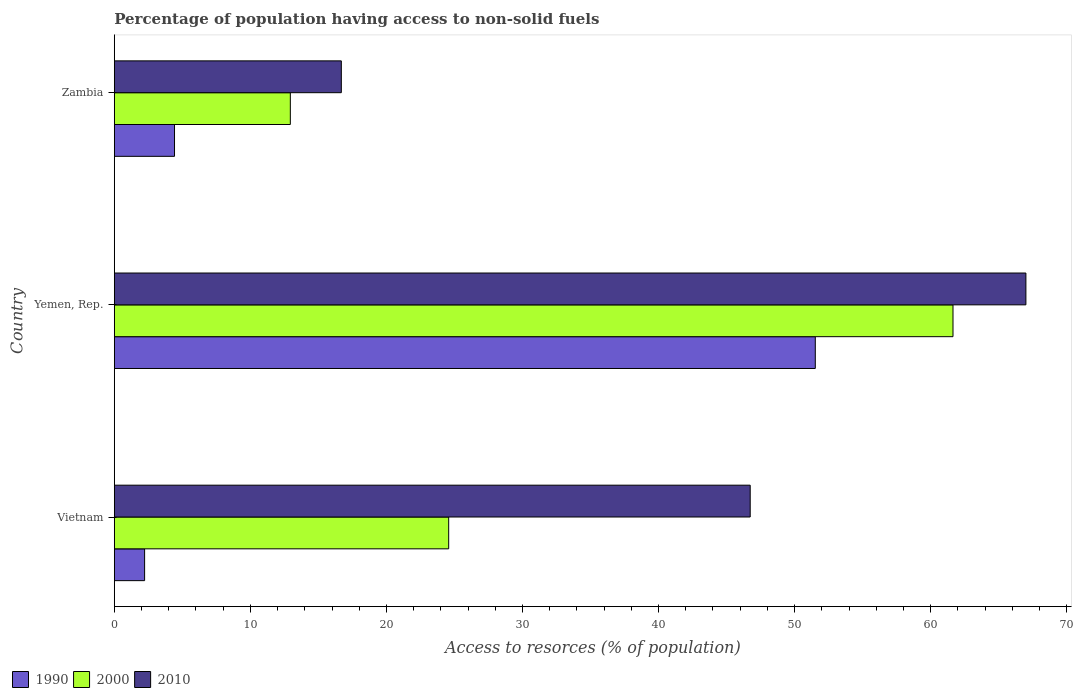Are the number of bars per tick equal to the number of legend labels?
Offer a terse response. Yes. How many bars are there on the 1st tick from the bottom?
Offer a terse response. 3. What is the label of the 2nd group of bars from the top?
Offer a very short reply. Yemen, Rep. What is the percentage of population having access to non-solid fuels in 2010 in Vietnam?
Offer a very short reply. 46.74. Across all countries, what is the maximum percentage of population having access to non-solid fuels in 2000?
Offer a terse response. 61.64. Across all countries, what is the minimum percentage of population having access to non-solid fuels in 1990?
Make the answer very short. 2.23. In which country was the percentage of population having access to non-solid fuels in 1990 maximum?
Ensure brevity in your answer.  Yemen, Rep. In which country was the percentage of population having access to non-solid fuels in 2000 minimum?
Keep it short and to the point. Zambia. What is the total percentage of population having access to non-solid fuels in 1990 in the graph?
Provide a succinct answer. 58.17. What is the difference between the percentage of population having access to non-solid fuels in 2000 in Vietnam and that in Yemen, Rep.?
Offer a terse response. -37.07. What is the difference between the percentage of population having access to non-solid fuels in 1990 in Yemen, Rep. and the percentage of population having access to non-solid fuels in 2000 in Zambia?
Provide a succinct answer. 38.58. What is the average percentage of population having access to non-solid fuels in 1990 per country?
Offer a terse response. 19.39. What is the difference between the percentage of population having access to non-solid fuels in 2010 and percentage of population having access to non-solid fuels in 2000 in Yemen, Rep.?
Give a very brief answer. 5.36. In how many countries, is the percentage of population having access to non-solid fuels in 1990 greater than 18 %?
Offer a terse response. 1. What is the ratio of the percentage of population having access to non-solid fuels in 2000 in Yemen, Rep. to that in Zambia?
Your response must be concise. 4.76. Is the percentage of population having access to non-solid fuels in 2000 in Yemen, Rep. less than that in Zambia?
Provide a short and direct response. No. What is the difference between the highest and the second highest percentage of population having access to non-solid fuels in 2000?
Keep it short and to the point. 37.07. What is the difference between the highest and the lowest percentage of population having access to non-solid fuels in 2010?
Your answer should be compact. 50.32. Is the sum of the percentage of population having access to non-solid fuels in 1990 in Vietnam and Yemen, Rep. greater than the maximum percentage of population having access to non-solid fuels in 2010 across all countries?
Your response must be concise. No. What does the 2nd bar from the bottom in Yemen, Rep. represents?
Give a very brief answer. 2000. Is it the case that in every country, the sum of the percentage of population having access to non-solid fuels in 2010 and percentage of population having access to non-solid fuels in 1990 is greater than the percentage of population having access to non-solid fuels in 2000?
Ensure brevity in your answer.  Yes. Are all the bars in the graph horizontal?
Your answer should be very brief. Yes. How many countries are there in the graph?
Keep it short and to the point. 3. What is the difference between two consecutive major ticks on the X-axis?
Keep it short and to the point. 10. Does the graph contain any zero values?
Provide a short and direct response. No. Does the graph contain grids?
Your response must be concise. No. What is the title of the graph?
Provide a succinct answer. Percentage of population having access to non-solid fuels. What is the label or title of the X-axis?
Provide a short and direct response. Access to resorces (% of population). What is the Access to resorces (% of population) in 1990 in Vietnam?
Make the answer very short. 2.23. What is the Access to resorces (% of population) of 2000 in Vietnam?
Your answer should be compact. 24.58. What is the Access to resorces (% of population) of 2010 in Vietnam?
Your answer should be compact. 46.74. What is the Access to resorces (% of population) of 1990 in Yemen, Rep.?
Your answer should be very brief. 51.52. What is the Access to resorces (% of population) in 2000 in Yemen, Rep.?
Ensure brevity in your answer.  61.64. What is the Access to resorces (% of population) of 2010 in Yemen, Rep.?
Ensure brevity in your answer.  67. What is the Access to resorces (% of population) in 1990 in Zambia?
Provide a short and direct response. 4.42. What is the Access to resorces (% of population) of 2000 in Zambia?
Your answer should be very brief. 12.94. What is the Access to resorces (% of population) in 2010 in Zambia?
Provide a short and direct response. 16.69. Across all countries, what is the maximum Access to resorces (% of population) in 1990?
Provide a succinct answer. 51.52. Across all countries, what is the maximum Access to resorces (% of population) in 2000?
Your response must be concise. 61.64. Across all countries, what is the maximum Access to resorces (% of population) of 2010?
Your answer should be compact. 67. Across all countries, what is the minimum Access to resorces (% of population) in 1990?
Provide a succinct answer. 2.23. Across all countries, what is the minimum Access to resorces (% of population) in 2000?
Provide a short and direct response. 12.94. Across all countries, what is the minimum Access to resorces (% of population) in 2010?
Your answer should be compact. 16.69. What is the total Access to resorces (% of population) in 1990 in the graph?
Offer a terse response. 58.17. What is the total Access to resorces (% of population) of 2000 in the graph?
Offer a terse response. 99.16. What is the total Access to resorces (% of population) in 2010 in the graph?
Your answer should be compact. 130.43. What is the difference between the Access to resorces (% of population) in 1990 in Vietnam and that in Yemen, Rep.?
Your answer should be compact. -49.29. What is the difference between the Access to resorces (% of population) of 2000 in Vietnam and that in Yemen, Rep.?
Provide a succinct answer. -37.07. What is the difference between the Access to resorces (% of population) of 2010 in Vietnam and that in Yemen, Rep.?
Your answer should be very brief. -20.26. What is the difference between the Access to resorces (% of population) of 1990 in Vietnam and that in Zambia?
Make the answer very short. -2.2. What is the difference between the Access to resorces (% of population) in 2000 in Vietnam and that in Zambia?
Provide a succinct answer. 11.64. What is the difference between the Access to resorces (% of population) of 2010 in Vietnam and that in Zambia?
Provide a succinct answer. 30.05. What is the difference between the Access to resorces (% of population) of 1990 in Yemen, Rep. and that in Zambia?
Make the answer very short. 47.1. What is the difference between the Access to resorces (% of population) of 2000 in Yemen, Rep. and that in Zambia?
Offer a terse response. 48.71. What is the difference between the Access to resorces (% of population) of 2010 in Yemen, Rep. and that in Zambia?
Give a very brief answer. 50.32. What is the difference between the Access to resorces (% of population) in 1990 in Vietnam and the Access to resorces (% of population) in 2000 in Yemen, Rep.?
Offer a very short reply. -59.42. What is the difference between the Access to resorces (% of population) of 1990 in Vietnam and the Access to resorces (% of population) of 2010 in Yemen, Rep.?
Offer a terse response. -64.78. What is the difference between the Access to resorces (% of population) in 2000 in Vietnam and the Access to resorces (% of population) in 2010 in Yemen, Rep.?
Keep it short and to the point. -42.43. What is the difference between the Access to resorces (% of population) in 1990 in Vietnam and the Access to resorces (% of population) in 2000 in Zambia?
Your answer should be compact. -10.71. What is the difference between the Access to resorces (% of population) in 1990 in Vietnam and the Access to resorces (% of population) in 2010 in Zambia?
Make the answer very short. -14.46. What is the difference between the Access to resorces (% of population) of 2000 in Vietnam and the Access to resorces (% of population) of 2010 in Zambia?
Provide a succinct answer. 7.89. What is the difference between the Access to resorces (% of population) in 1990 in Yemen, Rep. and the Access to resorces (% of population) in 2000 in Zambia?
Give a very brief answer. 38.58. What is the difference between the Access to resorces (% of population) in 1990 in Yemen, Rep. and the Access to resorces (% of population) in 2010 in Zambia?
Your answer should be compact. 34.84. What is the difference between the Access to resorces (% of population) in 2000 in Yemen, Rep. and the Access to resorces (% of population) in 2010 in Zambia?
Give a very brief answer. 44.96. What is the average Access to resorces (% of population) of 1990 per country?
Ensure brevity in your answer.  19.39. What is the average Access to resorces (% of population) of 2000 per country?
Keep it short and to the point. 33.05. What is the average Access to resorces (% of population) in 2010 per country?
Make the answer very short. 43.48. What is the difference between the Access to resorces (% of population) of 1990 and Access to resorces (% of population) of 2000 in Vietnam?
Your answer should be very brief. -22.35. What is the difference between the Access to resorces (% of population) of 1990 and Access to resorces (% of population) of 2010 in Vietnam?
Ensure brevity in your answer.  -44.51. What is the difference between the Access to resorces (% of population) of 2000 and Access to resorces (% of population) of 2010 in Vietnam?
Your response must be concise. -22.16. What is the difference between the Access to resorces (% of population) of 1990 and Access to resorces (% of population) of 2000 in Yemen, Rep.?
Give a very brief answer. -10.12. What is the difference between the Access to resorces (% of population) in 1990 and Access to resorces (% of population) in 2010 in Yemen, Rep.?
Offer a terse response. -15.48. What is the difference between the Access to resorces (% of population) in 2000 and Access to resorces (% of population) in 2010 in Yemen, Rep.?
Provide a short and direct response. -5.36. What is the difference between the Access to resorces (% of population) of 1990 and Access to resorces (% of population) of 2000 in Zambia?
Your response must be concise. -8.51. What is the difference between the Access to resorces (% of population) in 1990 and Access to resorces (% of population) in 2010 in Zambia?
Ensure brevity in your answer.  -12.26. What is the difference between the Access to resorces (% of population) of 2000 and Access to resorces (% of population) of 2010 in Zambia?
Keep it short and to the point. -3.75. What is the ratio of the Access to resorces (% of population) in 1990 in Vietnam to that in Yemen, Rep.?
Your answer should be very brief. 0.04. What is the ratio of the Access to resorces (% of population) in 2000 in Vietnam to that in Yemen, Rep.?
Ensure brevity in your answer.  0.4. What is the ratio of the Access to resorces (% of population) of 2010 in Vietnam to that in Yemen, Rep.?
Offer a terse response. 0.7. What is the ratio of the Access to resorces (% of population) of 1990 in Vietnam to that in Zambia?
Keep it short and to the point. 0.5. What is the ratio of the Access to resorces (% of population) in 2000 in Vietnam to that in Zambia?
Provide a succinct answer. 1.9. What is the ratio of the Access to resorces (% of population) of 2010 in Vietnam to that in Zambia?
Ensure brevity in your answer.  2.8. What is the ratio of the Access to resorces (% of population) in 1990 in Yemen, Rep. to that in Zambia?
Offer a very short reply. 11.64. What is the ratio of the Access to resorces (% of population) in 2000 in Yemen, Rep. to that in Zambia?
Keep it short and to the point. 4.76. What is the ratio of the Access to resorces (% of population) of 2010 in Yemen, Rep. to that in Zambia?
Offer a very short reply. 4.02. What is the difference between the highest and the second highest Access to resorces (% of population) of 1990?
Your response must be concise. 47.1. What is the difference between the highest and the second highest Access to resorces (% of population) of 2000?
Make the answer very short. 37.07. What is the difference between the highest and the second highest Access to resorces (% of population) in 2010?
Offer a very short reply. 20.26. What is the difference between the highest and the lowest Access to resorces (% of population) in 1990?
Provide a succinct answer. 49.29. What is the difference between the highest and the lowest Access to resorces (% of population) in 2000?
Your answer should be compact. 48.71. What is the difference between the highest and the lowest Access to resorces (% of population) in 2010?
Provide a short and direct response. 50.32. 